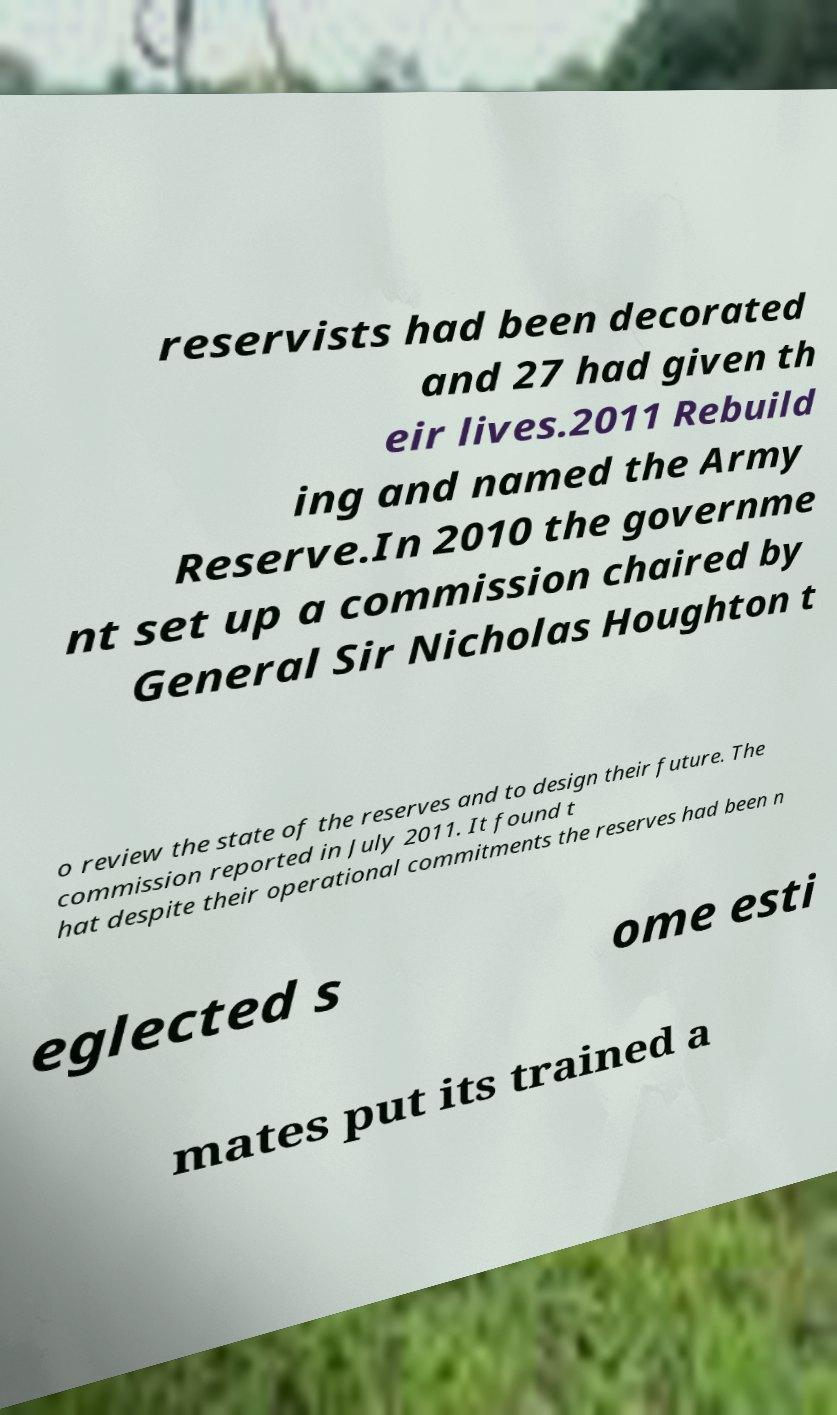Please identify and transcribe the text found in this image. reservists had been decorated and 27 had given th eir lives.2011 Rebuild ing and named the Army Reserve.In 2010 the governme nt set up a commission chaired by General Sir Nicholas Houghton t o review the state of the reserves and to design their future. The commission reported in July 2011. It found t hat despite their operational commitments the reserves had been n eglected s ome esti mates put its trained a 